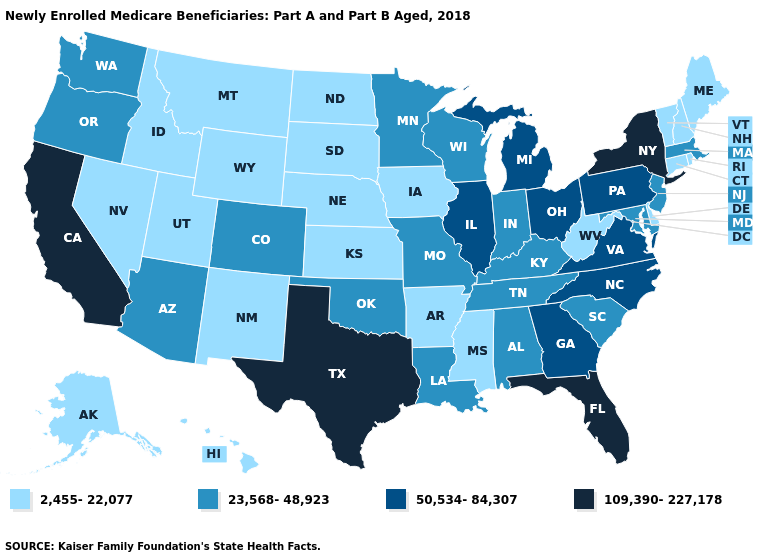What is the lowest value in the MidWest?
Short answer required. 2,455-22,077. Among the states that border Alabama , which have the highest value?
Be succinct. Florida. Does Hawaii have a higher value than North Dakota?
Quick response, please. No. Does North Dakota have the lowest value in the MidWest?
Answer briefly. Yes. Name the states that have a value in the range 2,455-22,077?
Be succinct. Alaska, Arkansas, Connecticut, Delaware, Hawaii, Idaho, Iowa, Kansas, Maine, Mississippi, Montana, Nebraska, Nevada, New Hampshire, New Mexico, North Dakota, Rhode Island, South Dakota, Utah, Vermont, West Virginia, Wyoming. What is the highest value in the USA?
Keep it brief. 109,390-227,178. How many symbols are there in the legend?
Be succinct. 4. Which states have the highest value in the USA?
Give a very brief answer. California, Florida, New York, Texas. Which states have the lowest value in the USA?
Be succinct. Alaska, Arkansas, Connecticut, Delaware, Hawaii, Idaho, Iowa, Kansas, Maine, Mississippi, Montana, Nebraska, Nevada, New Hampshire, New Mexico, North Dakota, Rhode Island, South Dakota, Utah, Vermont, West Virginia, Wyoming. Name the states that have a value in the range 2,455-22,077?
Quick response, please. Alaska, Arkansas, Connecticut, Delaware, Hawaii, Idaho, Iowa, Kansas, Maine, Mississippi, Montana, Nebraska, Nevada, New Hampshire, New Mexico, North Dakota, Rhode Island, South Dakota, Utah, Vermont, West Virginia, Wyoming. Name the states that have a value in the range 23,568-48,923?
Answer briefly. Alabama, Arizona, Colorado, Indiana, Kentucky, Louisiana, Maryland, Massachusetts, Minnesota, Missouri, New Jersey, Oklahoma, Oregon, South Carolina, Tennessee, Washington, Wisconsin. What is the lowest value in the MidWest?
Short answer required. 2,455-22,077. Does New Hampshire have the highest value in the Northeast?
Be succinct. No. Among the states that border Washington , which have the lowest value?
Give a very brief answer. Idaho. Name the states that have a value in the range 2,455-22,077?
Concise answer only. Alaska, Arkansas, Connecticut, Delaware, Hawaii, Idaho, Iowa, Kansas, Maine, Mississippi, Montana, Nebraska, Nevada, New Hampshire, New Mexico, North Dakota, Rhode Island, South Dakota, Utah, Vermont, West Virginia, Wyoming. 